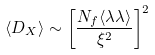Convert formula to latex. <formula><loc_0><loc_0><loc_500><loc_500>\langle D _ { X } \rangle \sim \left [ \frac { N _ { f } \langle \lambda \lambda \rangle } { \xi ^ { 2 } } \right ] ^ { 2 }</formula> 